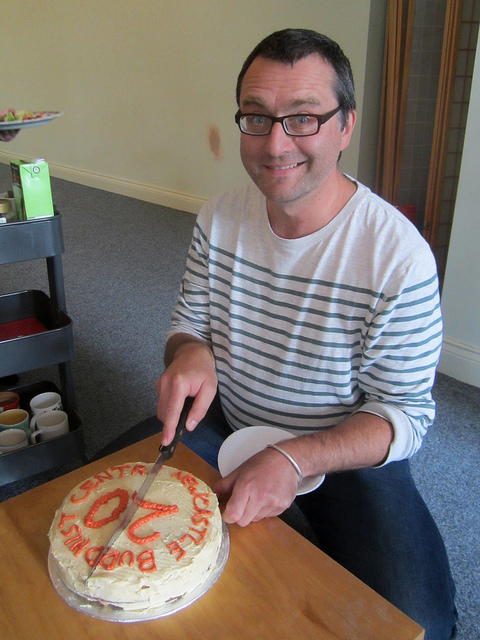Read and extract the text from this image. 20 